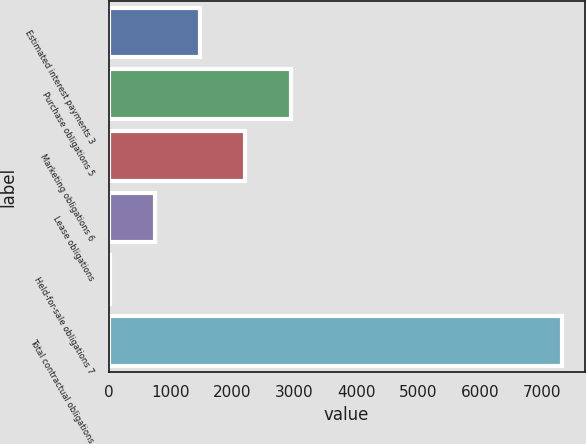<chart> <loc_0><loc_0><loc_500><loc_500><bar_chart><fcel>Estimated interest payments 3<fcel>Purchase obligations 5<fcel>Marketing obligations 6<fcel>Lease obligations<fcel>Held-for-sale obligations 7<fcel>Total contractual obligations<nl><fcel>1478.8<fcel>2940.6<fcel>2209.7<fcel>747.9<fcel>17<fcel>7326<nl></chart> 